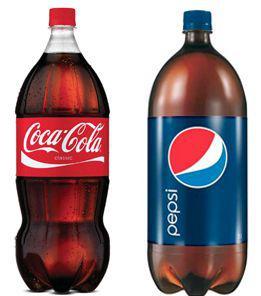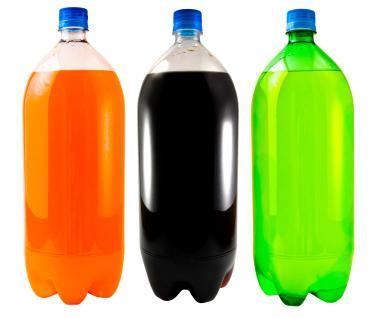The first image is the image on the left, the second image is the image on the right. Examine the images to the left and right. Is the description "There are five soda bottles in total." accurate? Answer yes or no. Yes. The first image is the image on the left, the second image is the image on the right. Examine the images to the left and right. Is the description "The left image contains two non-overlapping bottles, and the right image contains three non-overlapping bottles." accurate? Answer yes or no. Yes. 